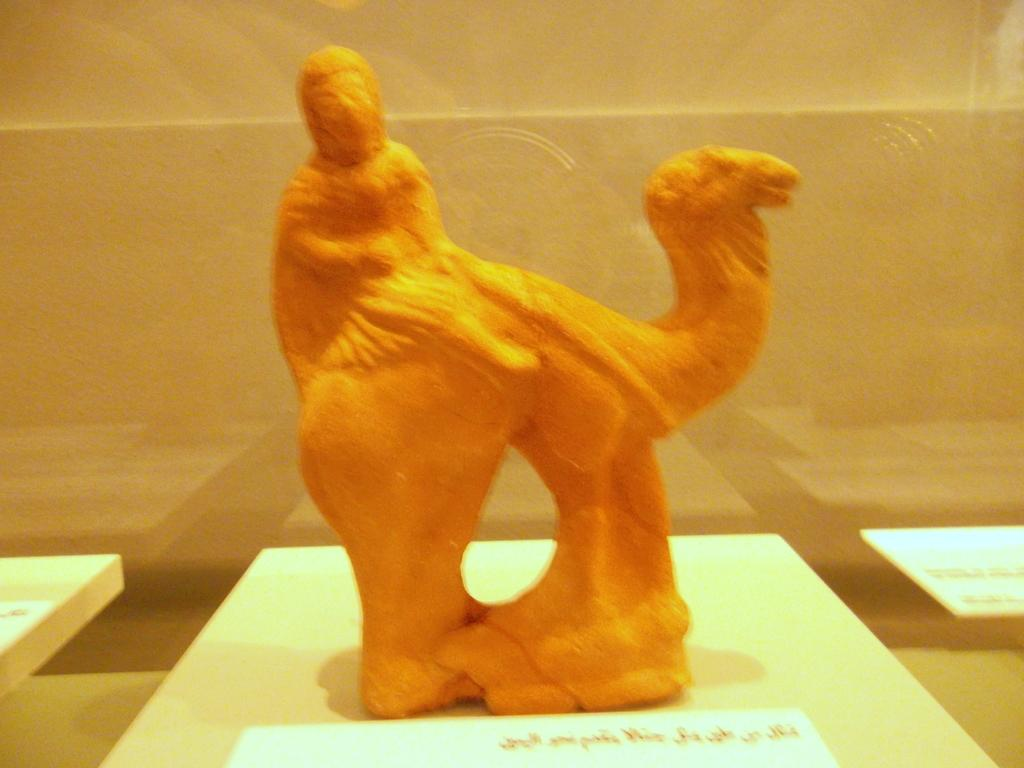What is the main subject of the image? There is an idol in the image. Where is the idol located? The idol is on a desk. What is the color of the idol? The idol is orange in color. What can be seen in the background of the image? There is a wall in the background of the image. Are there any ants crawling on the idol in the image? There is no indication of ants in the image; the focus is on the idol and its color and location. 